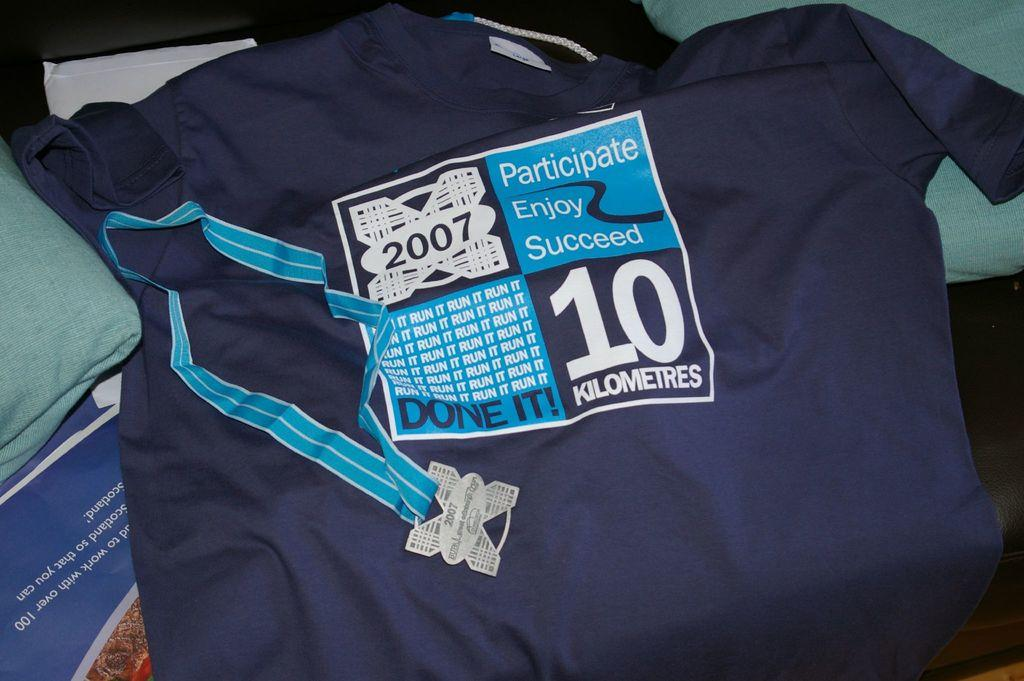<image>
Give a short and clear explanation of the subsequent image. A shirt that says Participate Enjoy Succeed on it. 